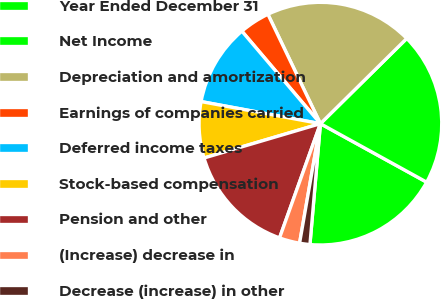<chart> <loc_0><loc_0><loc_500><loc_500><pie_chart><fcel>Year Ended December 31<fcel>Net Income<fcel>Depreciation and amortization<fcel>Earnings of companies carried<fcel>Deferred income taxes<fcel>Stock-based compensation<fcel>Pension and other<fcel>(Increase) decrease in<fcel>Decrease (increase) in other<nl><fcel>18.36%<fcel>20.4%<fcel>19.72%<fcel>4.08%<fcel>10.88%<fcel>7.48%<fcel>14.96%<fcel>2.72%<fcel>1.37%<nl></chart> 